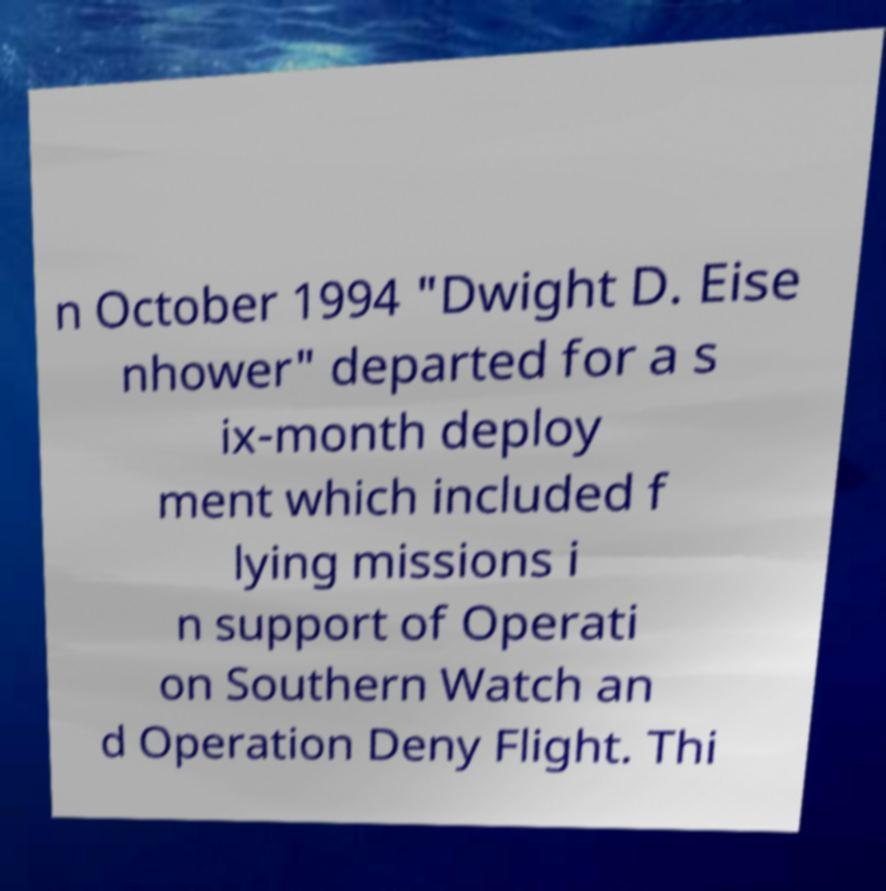There's text embedded in this image that I need extracted. Can you transcribe it verbatim? n October 1994 "Dwight D. Eise nhower" departed for a s ix-month deploy ment which included f lying missions i n support of Operati on Southern Watch an d Operation Deny Flight. Thi 